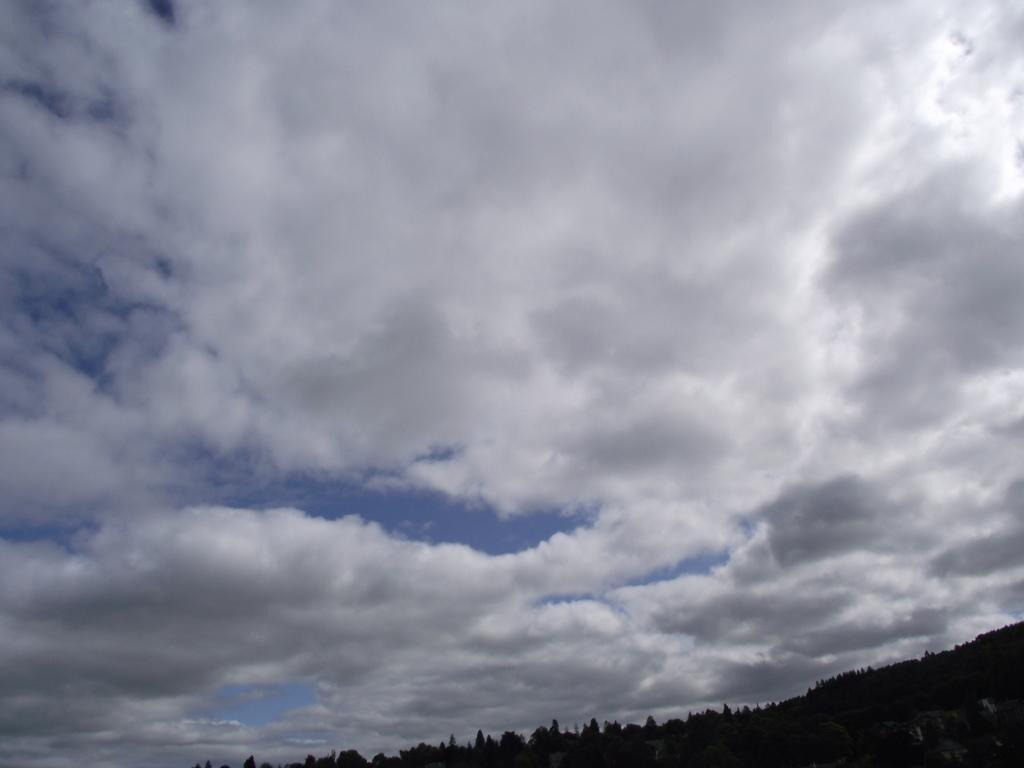Please provide a concise description of this image. This picture is clicked outside the city. In the foreground we can see the trees and some other objects. In the background there is a sky which is full of clouds. 